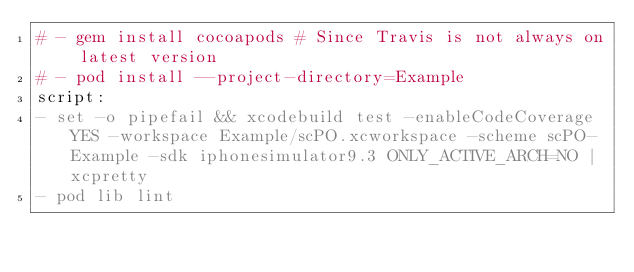<code> <loc_0><loc_0><loc_500><loc_500><_YAML_># - gem install cocoapods # Since Travis is not always on latest version
# - pod install --project-directory=Example
script:
- set -o pipefail && xcodebuild test -enableCodeCoverage YES -workspace Example/scPO.xcworkspace -scheme scPO-Example -sdk iphonesimulator9.3 ONLY_ACTIVE_ARCH=NO | xcpretty
- pod lib lint
</code> 